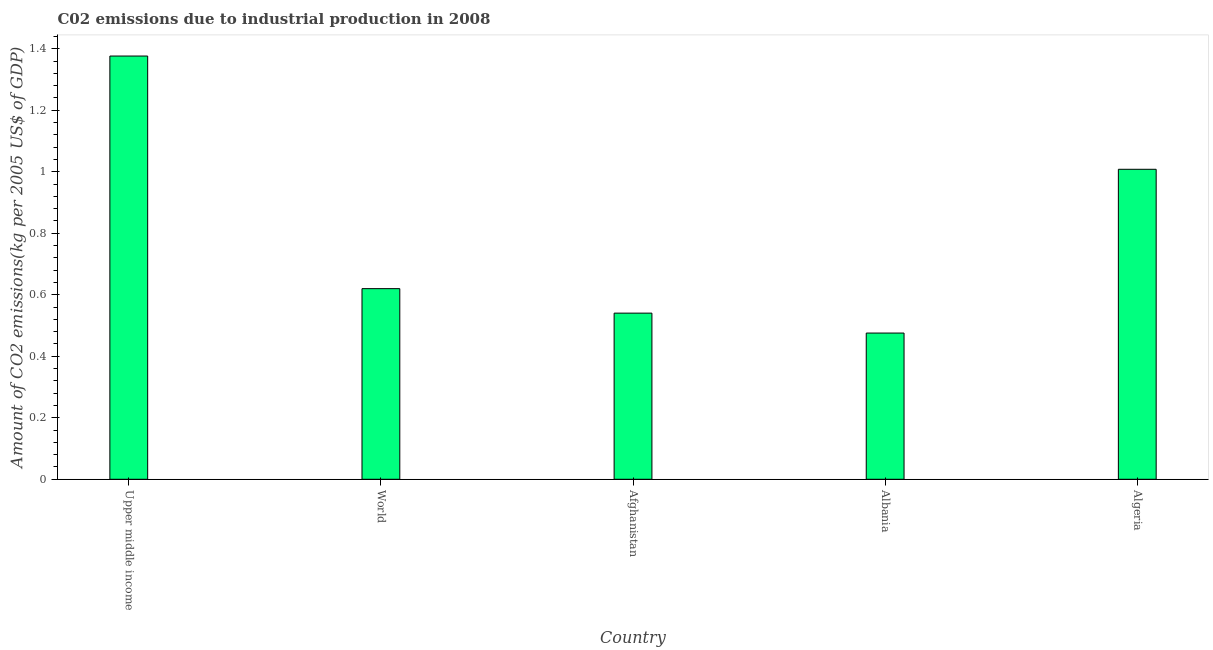Does the graph contain grids?
Ensure brevity in your answer.  No. What is the title of the graph?
Provide a succinct answer. C02 emissions due to industrial production in 2008. What is the label or title of the X-axis?
Offer a very short reply. Country. What is the label or title of the Y-axis?
Offer a terse response. Amount of CO2 emissions(kg per 2005 US$ of GDP). What is the amount of co2 emissions in Afghanistan?
Your answer should be compact. 0.54. Across all countries, what is the maximum amount of co2 emissions?
Provide a short and direct response. 1.38. Across all countries, what is the minimum amount of co2 emissions?
Give a very brief answer. 0.48. In which country was the amount of co2 emissions maximum?
Ensure brevity in your answer.  Upper middle income. In which country was the amount of co2 emissions minimum?
Give a very brief answer. Albania. What is the sum of the amount of co2 emissions?
Offer a terse response. 4.02. What is the difference between the amount of co2 emissions in Upper middle income and World?
Your answer should be very brief. 0.76. What is the average amount of co2 emissions per country?
Make the answer very short. 0.8. What is the median amount of co2 emissions?
Ensure brevity in your answer.  0.62. What is the ratio of the amount of co2 emissions in Afghanistan to that in Albania?
Ensure brevity in your answer.  1.14. Is the amount of co2 emissions in Upper middle income less than that in World?
Make the answer very short. No. Is the difference between the amount of co2 emissions in Afghanistan and Algeria greater than the difference between any two countries?
Your answer should be very brief. No. What is the difference between the highest and the second highest amount of co2 emissions?
Your answer should be very brief. 0.37. What is the difference between the highest and the lowest amount of co2 emissions?
Offer a very short reply. 0.9. How many bars are there?
Ensure brevity in your answer.  5. How many countries are there in the graph?
Your answer should be very brief. 5. What is the difference between two consecutive major ticks on the Y-axis?
Offer a terse response. 0.2. What is the Amount of CO2 emissions(kg per 2005 US$ of GDP) in Upper middle income?
Provide a succinct answer. 1.38. What is the Amount of CO2 emissions(kg per 2005 US$ of GDP) of World?
Your answer should be very brief. 0.62. What is the Amount of CO2 emissions(kg per 2005 US$ of GDP) in Afghanistan?
Keep it short and to the point. 0.54. What is the Amount of CO2 emissions(kg per 2005 US$ of GDP) of Albania?
Your answer should be compact. 0.48. What is the Amount of CO2 emissions(kg per 2005 US$ of GDP) in Algeria?
Your answer should be very brief. 1.01. What is the difference between the Amount of CO2 emissions(kg per 2005 US$ of GDP) in Upper middle income and World?
Offer a terse response. 0.76. What is the difference between the Amount of CO2 emissions(kg per 2005 US$ of GDP) in Upper middle income and Afghanistan?
Keep it short and to the point. 0.84. What is the difference between the Amount of CO2 emissions(kg per 2005 US$ of GDP) in Upper middle income and Albania?
Provide a short and direct response. 0.9. What is the difference between the Amount of CO2 emissions(kg per 2005 US$ of GDP) in Upper middle income and Algeria?
Keep it short and to the point. 0.37. What is the difference between the Amount of CO2 emissions(kg per 2005 US$ of GDP) in World and Afghanistan?
Ensure brevity in your answer.  0.08. What is the difference between the Amount of CO2 emissions(kg per 2005 US$ of GDP) in World and Albania?
Offer a terse response. 0.14. What is the difference between the Amount of CO2 emissions(kg per 2005 US$ of GDP) in World and Algeria?
Ensure brevity in your answer.  -0.39. What is the difference between the Amount of CO2 emissions(kg per 2005 US$ of GDP) in Afghanistan and Albania?
Ensure brevity in your answer.  0.06. What is the difference between the Amount of CO2 emissions(kg per 2005 US$ of GDP) in Afghanistan and Algeria?
Ensure brevity in your answer.  -0.47. What is the difference between the Amount of CO2 emissions(kg per 2005 US$ of GDP) in Albania and Algeria?
Offer a very short reply. -0.53. What is the ratio of the Amount of CO2 emissions(kg per 2005 US$ of GDP) in Upper middle income to that in World?
Give a very brief answer. 2.22. What is the ratio of the Amount of CO2 emissions(kg per 2005 US$ of GDP) in Upper middle income to that in Afghanistan?
Your answer should be very brief. 2.55. What is the ratio of the Amount of CO2 emissions(kg per 2005 US$ of GDP) in Upper middle income to that in Albania?
Your response must be concise. 2.9. What is the ratio of the Amount of CO2 emissions(kg per 2005 US$ of GDP) in Upper middle income to that in Algeria?
Offer a very short reply. 1.36. What is the ratio of the Amount of CO2 emissions(kg per 2005 US$ of GDP) in World to that in Afghanistan?
Your response must be concise. 1.15. What is the ratio of the Amount of CO2 emissions(kg per 2005 US$ of GDP) in World to that in Albania?
Your answer should be very brief. 1.3. What is the ratio of the Amount of CO2 emissions(kg per 2005 US$ of GDP) in World to that in Algeria?
Offer a very short reply. 0.61. What is the ratio of the Amount of CO2 emissions(kg per 2005 US$ of GDP) in Afghanistan to that in Albania?
Your answer should be very brief. 1.14. What is the ratio of the Amount of CO2 emissions(kg per 2005 US$ of GDP) in Afghanistan to that in Algeria?
Ensure brevity in your answer.  0.54. What is the ratio of the Amount of CO2 emissions(kg per 2005 US$ of GDP) in Albania to that in Algeria?
Your answer should be compact. 0.47. 